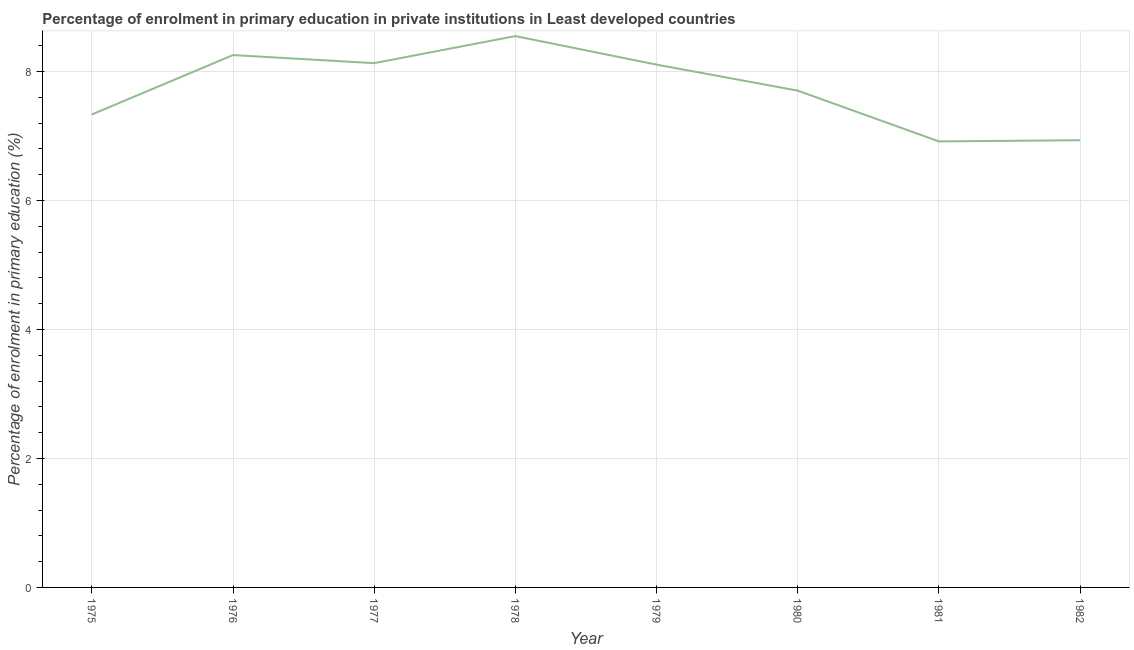What is the enrolment percentage in primary education in 1981?
Ensure brevity in your answer.  6.92. Across all years, what is the maximum enrolment percentage in primary education?
Ensure brevity in your answer.  8.55. Across all years, what is the minimum enrolment percentage in primary education?
Your answer should be very brief. 6.92. In which year was the enrolment percentage in primary education maximum?
Provide a succinct answer. 1978. What is the sum of the enrolment percentage in primary education?
Ensure brevity in your answer.  61.92. What is the difference between the enrolment percentage in primary education in 1975 and 1978?
Ensure brevity in your answer.  -1.22. What is the average enrolment percentage in primary education per year?
Ensure brevity in your answer.  7.74. What is the median enrolment percentage in primary education?
Your response must be concise. 7.9. In how many years, is the enrolment percentage in primary education greater than 8 %?
Ensure brevity in your answer.  4. Do a majority of the years between 1977 and 1980 (inclusive) have enrolment percentage in primary education greater than 5.2 %?
Provide a short and direct response. Yes. What is the ratio of the enrolment percentage in primary education in 1978 to that in 1979?
Keep it short and to the point. 1.05. Is the difference between the enrolment percentage in primary education in 1976 and 1980 greater than the difference between any two years?
Your answer should be compact. No. What is the difference between the highest and the second highest enrolment percentage in primary education?
Your answer should be compact. 0.29. What is the difference between the highest and the lowest enrolment percentage in primary education?
Make the answer very short. 1.63. How many lines are there?
Offer a terse response. 1. What is the difference between two consecutive major ticks on the Y-axis?
Ensure brevity in your answer.  2. What is the title of the graph?
Offer a very short reply. Percentage of enrolment in primary education in private institutions in Least developed countries. What is the label or title of the X-axis?
Offer a very short reply. Year. What is the label or title of the Y-axis?
Make the answer very short. Percentage of enrolment in primary education (%). What is the Percentage of enrolment in primary education (%) in 1975?
Ensure brevity in your answer.  7.33. What is the Percentage of enrolment in primary education (%) of 1976?
Ensure brevity in your answer.  8.25. What is the Percentage of enrolment in primary education (%) of 1977?
Provide a succinct answer. 8.13. What is the Percentage of enrolment in primary education (%) of 1978?
Your answer should be compact. 8.55. What is the Percentage of enrolment in primary education (%) in 1979?
Give a very brief answer. 8.11. What is the Percentage of enrolment in primary education (%) in 1980?
Your response must be concise. 7.7. What is the Percentage of enrolment in primary education (%) of 1981?
Keep it short and to the point. 6.92. What is the Percentage of enrolment in primary education (%) of 1982?
Your response must be concise. 6.93. What is the difference between the Percentage of enrolment in primary education (%) in 1975 and 1976?
Give a very brief answer. -0.92. What is the difference between the Percentage of enrolment in primary education (%) in 1975 and 1977?
Give a very brief answer. -0.8. What is the difference between the Percentage of enrolment in primary education (%) in 1975 and 1978?
Provide a succinct answer. -1.22. What is the difference between the Percentage of enrolment in primary education (%) in 1975 and 1979?
Your response must be concise. -0.77. What is the difference between the Percentage of enrolment in primary education (%) in 1975 and 1980?
Provide a succinct answer. -0.37. What is the difference between the Percentage of enrolment in primary education (%) in 1975 and 1981?
Keep it short and to the point. 0.42. What is the difference between the Percentage of enrolment in primary education (%) in 1975 and 1982?
Provide a succinct answer. 0.4. What is the difference between the Percentage of enrolment in primary education (%) in 1976 and 1977?
Your answer should be compact. 0.13. What is the difference between the Percentage of enrolment in primary education (%) in 1976 and 1978?
Your response must be concise. -0.29. What is the difference between the Percentage of enrolment in primary education (%) in 1976 and 1979?
Your response must be concise. 0.15. What is the difference between the Percentage of enrolment in primary education (%) in 1976 and 1980?
Keep it short and to the point. 0.55. What is the difference between the Percentage of enrolment in primary education (%) in 1976 and 1981?
Provide a succinct answer. 1.34. What is the difference between the Percentage of enrolment in primary education (%) in 1976 and 1982?
Make the answer very short. 1.32. What is the difference between the Percentage of enrolment in primary education (%) in 1977 and 1978?
Offer a terse response. -0.42. What is the difference between the Percentage of enrolment in primary education (%) in 1977 and 1979?
Offer a very short reply. 0.02. What is the difference between the Percentage of enrolment in primary education (%) in 1977 and 1980?
Your answer should be very brief. 0.43. What is the difference between the Percentage of enrolment in primary education (%) in 1977 and 1981?
Provide a succinct answer. 1.21. What is the difference between the Percentage of enrolment in primary education (%) in 1977 and 1982?
Provide a short and direct response. 1.2. What is the difference between the Percentage of enrolment in primary education (%) in 1978 and 1979?
Your answer should be very brief. 0.44. What is the difference between the Percentage of enrolment in primary education (%) in 1978 and 1980?
Your response must be concise. 0.85. What is the difference between the Percentage of enrolment in primary education (%) in 1978 and 1981?
Provide a short and direct response. 1.63. What is the difference between the Percentage of enrolment in primary education (%) in 1978 and 1982?
Give a very brief answer. 1.61. What is the difference between the Percentage of enrolment in primary education (%) in 1979 and 1980?
Give a very brief answer. 0.4. What is the difference between the Percentage of enrolment in primary education (%) in 1979 and 1981?
Ensure brevity in your answer.  1.19. What is the difference between the Percentage of enrolment in primary education (%) in 1979 and 1982?
Your answer should be compact. 1.17. What is the difference between the Percentage of enrolment in primary education (%) in 1980 and 1981?
Provide a succinct answer. 0.79. What is the difference between the Percentage of enrolment in primary education (%) in 1980 and 1982?
Your response must be concise. 0.77. What is the difference between the Percentage of enrolment in primary education (%) in 1981 and 1982?
Provide a short and direct response. -0.02. What is the ratio of the Percentage of enrolment in primary education (%) in 1975 to that in 1976?
Keep it short and to the point. 0.89. What is the ratio of the Percentage of enrolment in primary education (%) in 1975 to that in 1977?
Your response must be concise. 0.9. What is the ratio of the Percentage of enrolment in primary education (%) in 1975 to that in 1978?
Offer a terse response. 0.86. What is the ratio of the Percentage of enrolment in primary education (%) in 1975 to that in 1979?
Make the answer very short. 0.91. What is the ratio of the Percentage of enrolment in primary education (%) in 1975 to that in 1980?
Give a very brief answer. 0.95. What is the ratio of the Percentage of enrolment in primary education (%) in 1975 to that in 1981?
Your response must be concise. 1.06. What is the ratio of the Percentage of enrolment in primary education (%) in 1975 to that in 1982?
Make the answer very short. 1.06. What is the ratio of the Percentage of enrolment in primary education (%) in 1976 to that in 1979?
Your answer should be compact. 1.02. What is the ratio of the Percentage of enrolment in primary education (%) in 1976 to that in 1980?
Provide a short and direct response. 1.07. What is the ratio of the Percentage of enrolment in primary education (%) in 1976 to that in 1981?
Ensure brevity in your answer.  1.19. What is the ratio of the Percentage of enrolment in primary education (%) in 1976 to that in 1982?
Give a very brief answer. 1.19. What is the ratio of the Percentage of enrolment in primary education (%) in 1977 to that in 1978?
Offer a very short reply. 0.95. What is the ratio of the Percentage of enrolment in primary education (%) in 1977 to that in 1979?
Keep it short and to the point. 1. What is the ratio of the Percentage of enrolment in primary education (%) in 1977 to that in 1980?
Ensure brevity in your answer.  1.05. What is the ratio of the Percentage of enrolment in primary education (%) in 1977 to that in 1981?
Your answer should be compact. 1.18. What is the ratio of the Percentage of enrolment in primary education (%) in 1977 to that in 1982?
Make the answer very short. 1.17. What is the ratio of the Percentage of enrolment in primary education (%) in 1978 to that in 1979?
Ensure brevity in your answer.  1.05. What is the ratio of the Percentage of enrolment in primary education (%) in 1978 to that in 1980?
Your answer should be very brief. 1.11. What is the ratio of the Percentage of enrolment in primary education (%) in 1978 to that in 1981?
Give a very brief answer. 1.24. What is the ratio of the Percentage of enrolment in primary education (%) in 1978 to that in 1982?
Your answer should be very brief. 1.23. What is the ratio of the Percentage of enrolment in primary education (%) in 1979 to that in 1980?
Provide a short and direct response. 1.05. What is the ratio of the Percentage of enrolment in primary education (%) in 1979 to that in 1981?
Offer a very short reply. 1.17. What is the ratio of the Percentage of enrolment in primary education (%) in 1979 to that in 1982?
Provide a short and direct response. 1.17. What is the ratio of the Percentage of enrolment in primary education (%) in 1980 to that in 1981?
Your response must be concise. 1.11. What is the ratio of the Percentage of enrolment in primary education (%) in 1980 to that in 1982?
Make the answer very short. 1.11. 